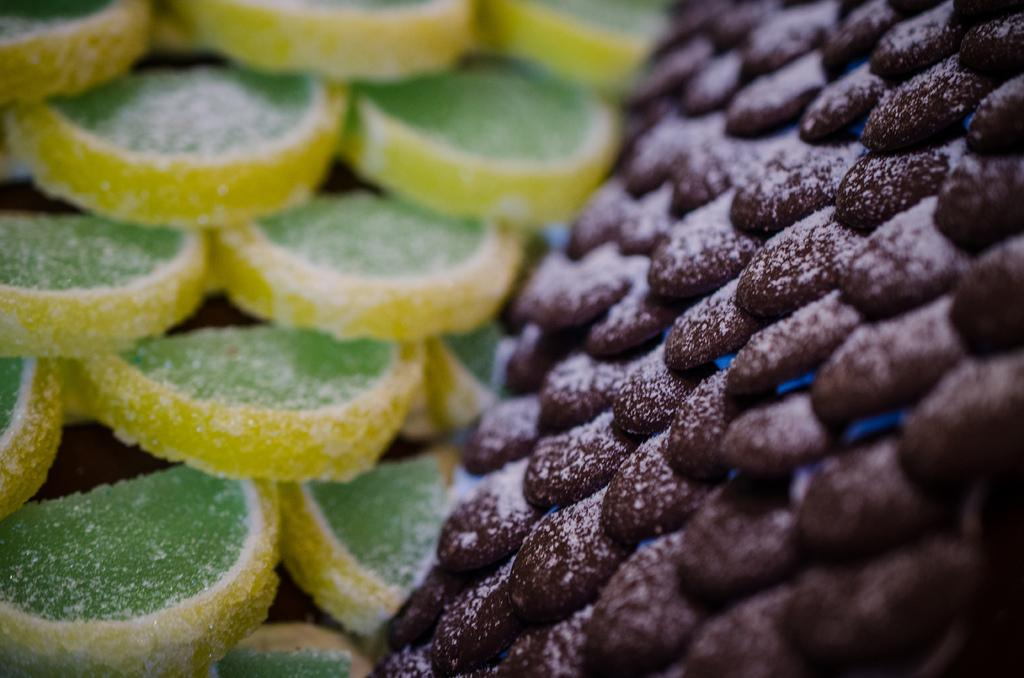What type of sweets can be seen in the image? There are sugar candies visible in the image. Can you describe the appearance of the sugar candies? The sugar candies appear to be colorful and small in size. Are the sugar candies arranged in any particular pattern or design? The provided facts do not mention any specific pattern or design for the sugar candies. What type of journey is depicted in the image? There is no journey depicted in the image; it only features sugar candies. Can you tell me how many toes are visible in the image? There are no toes visible in the image; it only features sugar candies. 